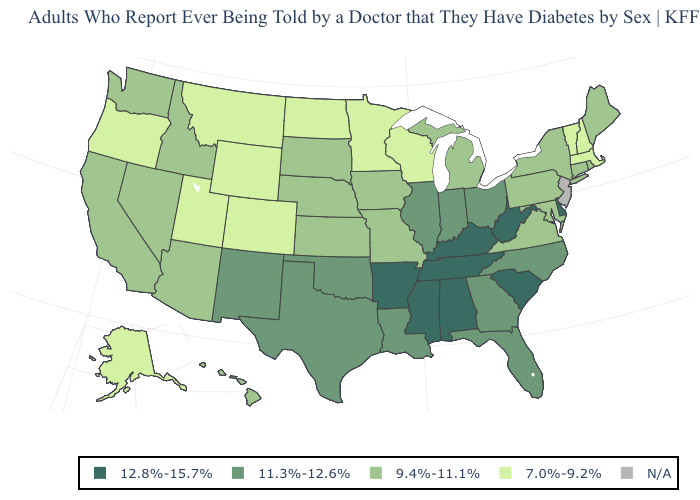Does Kentucky have the highest value in the South?
Answer briefly. Yes. Name the states that have a value in the range 9.4%-11.1%?
Quick response, please. Arizona, California, Connecticut, Hawaii, Idaho, Iowa, Kansas, Maine, Maryland, Michigan, Missouri, Nebraska, Nevada, New York, Pennsylvania, Rhode Island, South Dakota, Virginia, Washington. What is the highest value in the USA?
Quick response, please. 12.8%-15.7%. Name the states that have a value in the range N/A?
Quick response, please. New Jersey. What is the highest value in states that border Montana?
Keep it brief. 9.4%-11.1%. What is the lowest value in the MidWest?
Be succinct. 7.0%-9.2%. Name the states that have a value in the range 12.8%-15.7%?
Concise answer only. Alabama, Arkansas, Delaware, Kentucky, Mississippi, South Carolina, Tennessee, West Virginia. Name the states that have a value in the range 9.4%-11.1%?
Answer briefly. Arizona, California, Connecticut, Hawaii, Idaho, Iowa, Kansas, Maine, Maryland, Michigan, Missouri, Nebraska, Nevada, New York, Pennsylvania, Rhode Island, South Dakota, Virginia, Washington. Does the map have missing data?
Concise answer only. Yes. Among the states that border Minnesota , does Iowa have the highest value?
Quick response, please. Yes. Name the states that have a value in the range 12.8%-15.7%?
Answer briefly. Alabama, Arkansas, Delaware, Kentucky, Mississippi, South Carolina, Tennessee, West Virginia. Name the states that have a value in the range 7.0%-9.2%?
Write a very short answer. Alaska, Colorado, Massachusetts, Minnesota, Montana, New Hampshire, North Dakota, Oregon, Utah, Vermont, Wisconsin, Wyoming. Among the states that border Michigan , which have the lowest value?
Give a very brief answer. Wisconsin. What is the value of Vermont?
Keep it brief. 7.0%-9.2%. Among the states that border Rhode Island , does Massachusetts have the highest value?
Give a very brief answer. No. 